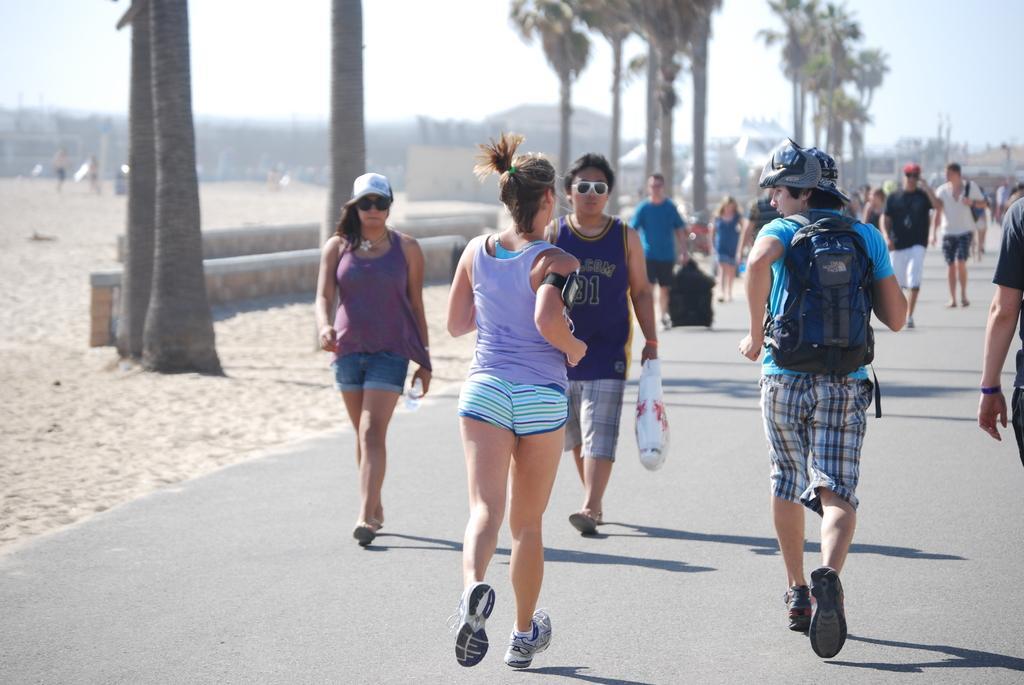Can you describe this image briefly? In this picture there is a boy and a girl in the center of the image, they are running and there are other people in the image, there are buildings in the background area of the image and there is a muddy floor on the left side of the image, there are logs in the image. 